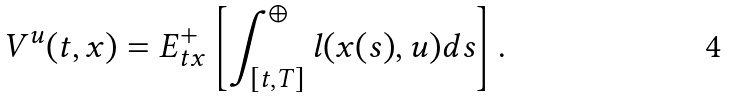Convert formula to latex. <formula><loc_0><loc_0><loc_500><loc_500>V ^ { u } ( t , x ) = E ^ { + } _ { t x } \left [ \int _ { [ t , T ] } ^ { \oplus } l ( x ( s ) , u ) d s \right ] .</formula> 